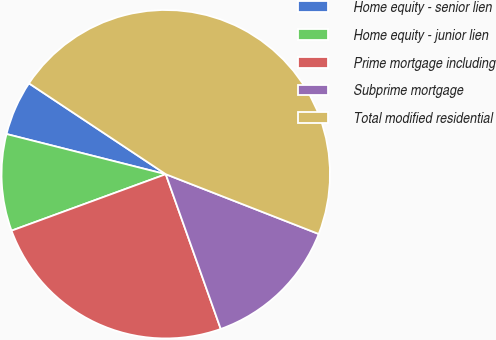<chart> <loc_0><loc_0><loc_500><loc_500><pie_chart><fcel>Home equity - senior lien<fcel>Home equity - junior lien<fcel>Prime mortgage including<fcel>Subprime mortgage<fcel>Total modified residential<nl><fcel>5.4%<fcel>9.52%<fcel>24.85%<fcel>13.64%<fcel>46.6%<nl></chart> 